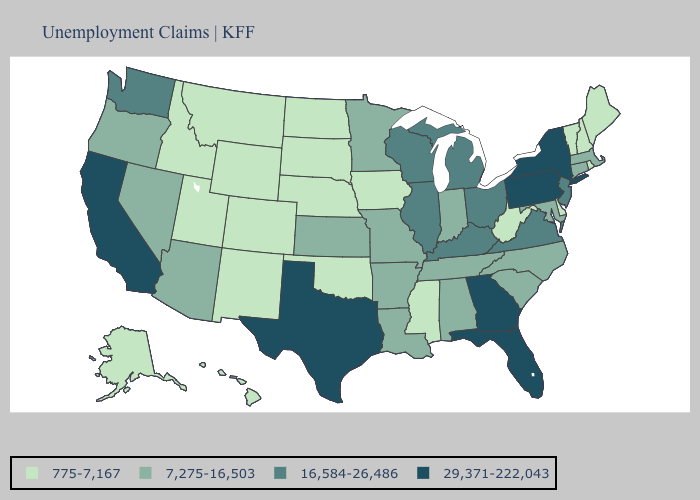Name the states that have a value in the range 16,584-26,486?
Quick response, please. Illinois, Kentucky, Michigan, New Jersey, Ohio, Virginia, Washington, Wisconsin. Among the states that border West Virginia , does Kentucky have the lowest value?
Be succinct. No. What is the value of Kansas?
Keep it brief. 7,275-16,503. Which states have the lowest value in the USA?
Short answer required. Alaska, Colorado, Delaware, Hawaii, Idaho, Iowa, Maine, Mississippi, Montana, Nebraska, New Hampshire, New Mexico, North Dakota, Oklahoma, Rhode Island, South Dakota, Utah, Vermont, West Virginia, Wyoming. Does Arizona have the lowest value in the West?
Be succinct. No. Among the states that border Colorado , which have the lowest value?
Quick response, please. Nebraska, New Mexico, Oklahoma, Utah, Wyoming. What is the value of Montana?
Answer briefly. 775-7,167. Among the states that border North Dakota , does South Dakota have the highest value?
Be succinct. No. What is the highest value in the USA?
Concise answer only. 29,371-222,043. What is the value of Nebraska?
Write a very short answer. 775-7,167. Is the legend a continuous bar?
Be succinct. No. Which states have the highest value in the USA?
Keep it brief. California, Florida, Georgia, New York, Pennsylvania, Texas. Name the states that have a value in the range 16,584-26,486?
Keep it brief. Illinois, Kentucky, Michigan, New Jersey, Ohio, Virginia, Washington, Wisconsin. Does Vermont have a lower value than South Dakota?
Concise answer only. No. Does Montana have the lowest value in the USA?
Concise answer only. Yes. 